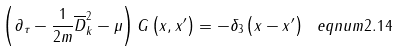Convert formula to latex. <formula><loc_0><loc_0><loc_500><loc_500>\left ( \partial _ { \tau } - \frac { 1 } { 2 m } \overline { D } _ { k } ^ { 2 } - \mu \right ) G \left ( x , x ^ { \prime } \right ) = - \delta _ { 3 } \left ( x - x ^ { \prime } \right ) \ e q n u m { 2 . 1 4 }</formula> 